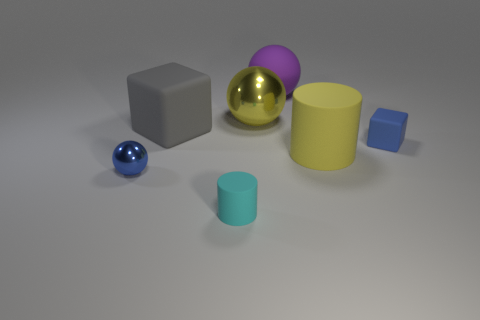Are there more cylinders in front of the large rubber cylinder than matte cylinders that are on the right side of the small matte cube?
Offer a terse response. Yes. The gray thing has what shape?
Keep it short and to the point. Cube. Does the large thing that is in front of the gray rubber object have the same material as the block to the left of the large rubber cylinder?
Make the answer very short. Yes. There is a tiny rubber object that is in front of the small ball; what shape is it?
Offer a very short reply. Cylinder. What size is the yellow matte thing that is the same shape as the small cyan rubber thing?
Give a very brief answer. Large. Is the color of the tiny metal sphere the same as the large matte cylinder?
Ensure brevity in your answer.  No. Is there any other thing that has the same shape as the small blue matte object?
Give a very brief answer. Yes. Are there any matte cylinders to the right of the matte thing in front of the yellow rubber thing?
Your response must be concise. Yes. The other object that is the same shape as the small cyan thing is what color?
Offer a terse response. Yellow. What number of other things are the same color as the small metal thing?
Offer a terse response. 1. 